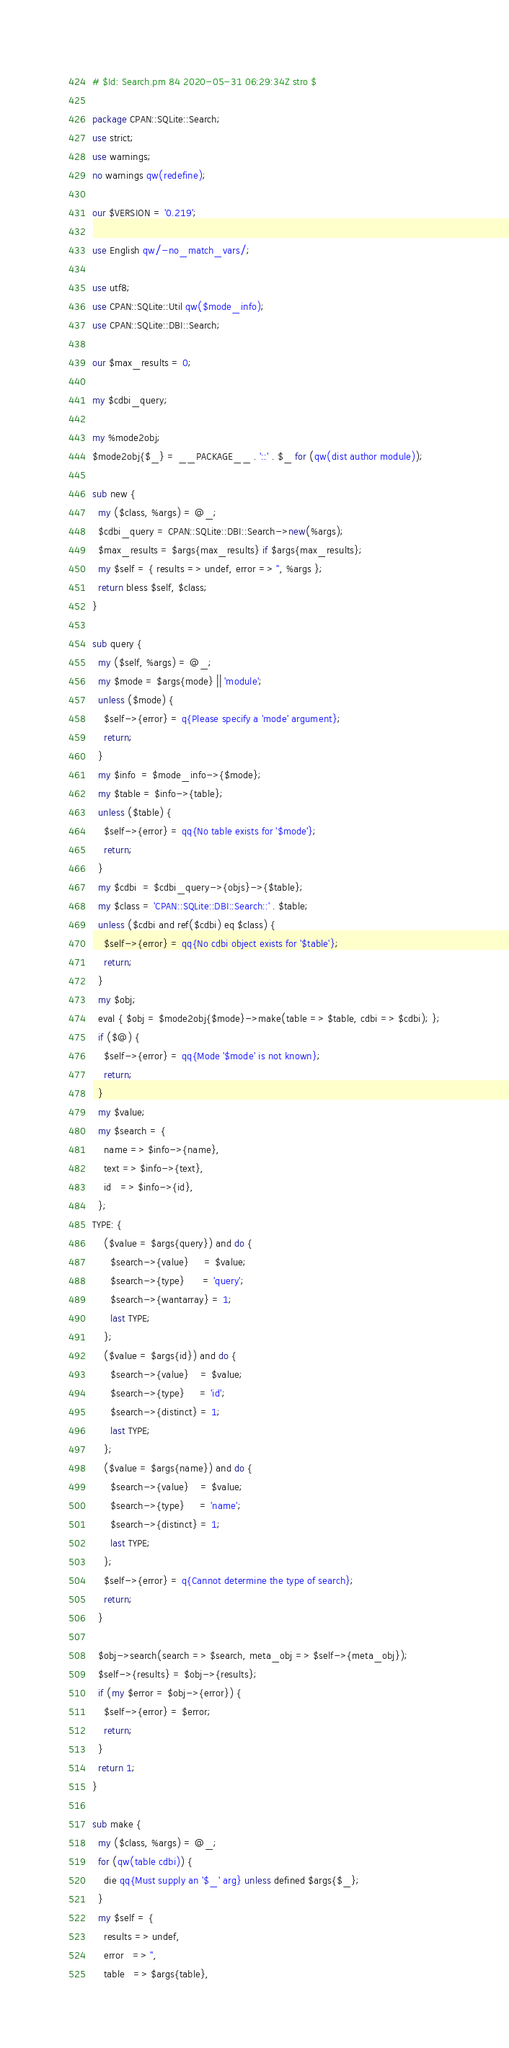<code> <loc_0><loc_0><loc_500><loc_500><_Perl_># $Id: Search.pm 84 2020-05-31 06:29:34Z stro $

package CPAN::SQLite::Search;
use strict;
use warnings;
no warnings qw(redefine);

our $VERSION = '0.219';

use English qw/-no_match_vars/;

use utf8;
use CPAN::SQLite::Util qw($mode_info);
use CPAN::SQLite::DBI::Search;

our $max_results = 0;

my $cdbi_query;

my %mode2obj;
$mode2obj{$_} = __PACKAGE__ . '::' . $_ for (qw(dist author module));

sub new {
  my ($class, %args) = @_;
  $cdbi_query = CPAN::SQLite::DBI::Search->new(%args);
  $max_results = $args{max_results} if $args{max_results};
  my $self = { results => undef, error => '', %args };
  return bless $self, $class;
}

sub query {
  my ($self, %args) = @_;
  my $mode = $args{mode} || 'module';
  unless ($mode) {
    $self->{error} = q{Please specify a 'mode' argument};
    return;
  }
  my $info  = $mode_info->{$mode};
  my $table = $info->{table};
  unless ($table) {
    $self->{error} = qq{No table exists for '$mode'};
    return;
  }
  my $cdbi  = $cdbi_query->{objs}->{$table};
  my $class = 'CPAN::SQLite::DBI::Search::' . $table;
  unless ($cdbi and ref($cdbi) eq $class) {
    $self->{error} = qq{No cdbi object exists for '$table'};
    return;
  }
  my $obj;
  eval { $obj = $mode2obj{$mode}->make(table => $table, cdbi => $cdbi); };
  if ($@) {
    $self->{error} = qq{Mode '$mode' is not known};
    return;
  }
  my $value;
  my $search = {
    name => $info->{name},
    text => $info->{text},
    id   => $info->{id},
  };
TYPE: {
    ($value = $args{query}) and do {
      $search->{value}     = $value;
      $search->{type}      = 'query';
      $search->{wantarray} = 1;
      last TYPE;
    };
    ($value = $args{id}) and do {
      $search->{value}    = $value;
      $search->{type}     = 'id';
      $search->{distinct} = 1;
      last TYPE;
    };
    ($value = $args{name}) and do {
      $search->{value}    = $value;
      $search->{type}     = 'name';
      $search->{distinct} = 1;
      last TYPE;
    };
    $self->{error} = q{Cannot determine the type of search};
    return;
  }

  $obj->search(search => $search, meta_obj => $self->{meta_obj});
  $self->{results} = $obj->{results};
  if (my $error = $obj->{error}) {
    $self->{error} = $error;
    return;
  }
  return 1;
}

sub make {
  my ($class, %args) = @_;
  for (qw(table cdbi)) {
    die qq{Must supply an '$_' arg} unless defined $args{$_};
  }
  my $self = {
    results => undef,
    error   => '',
    table   => $args{table},</code> 